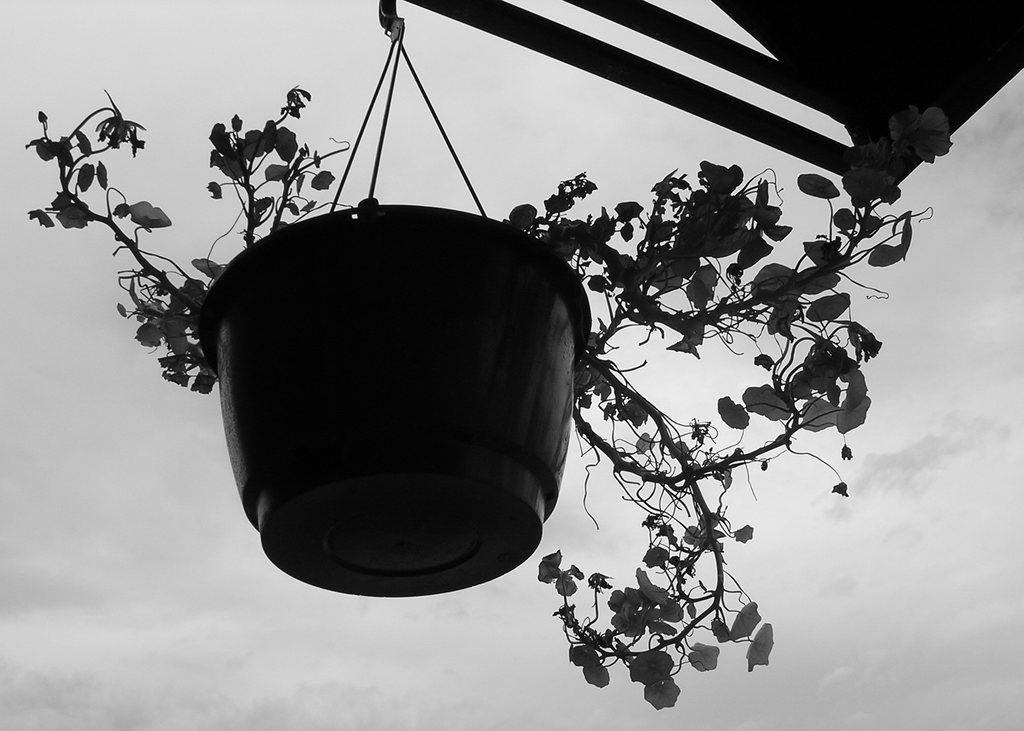What object is hanging on a shed in the image? There is a plant pot hanging on a shed in the image. What can be seen in the background of the image? There is a sky visible in the background of the image. What is present in the sky? There are clouds in the sky. What type of knife can be seen being used to expand the shed in the image? There is no knife or expansion activity present in the image. What type of twig can be seen growing from the plant pot in the image? There is no twig growing from the plant pot in the image; only the plant pot itself is visible. 